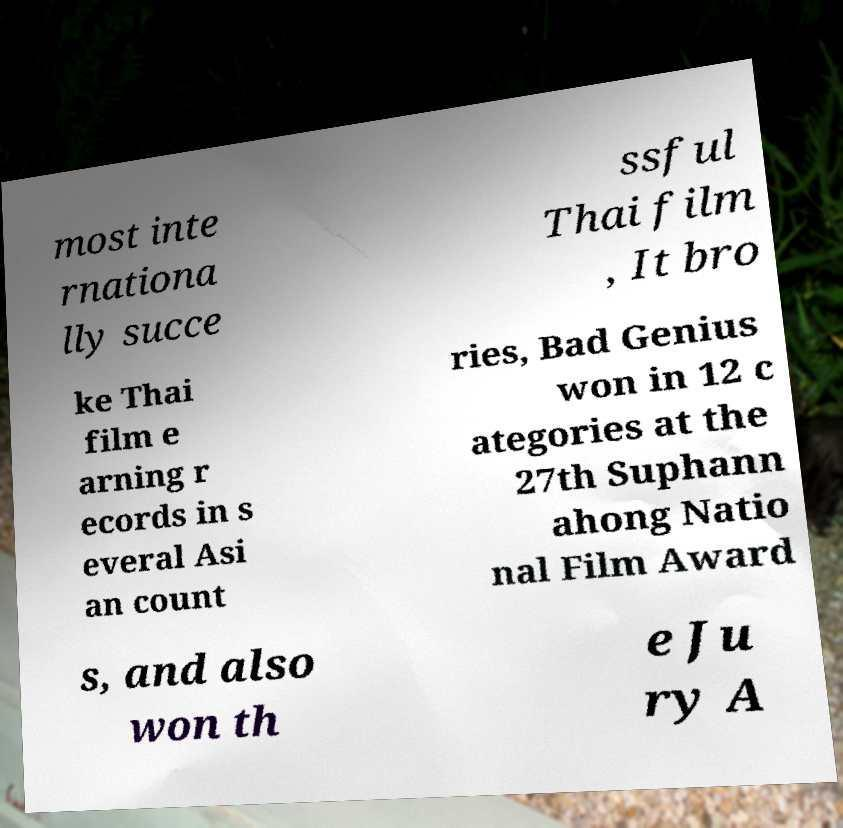I need the written content from this picture converted into text. Can you do that? most inte rnationa lly succe ssful Thai film , It bro ke Thai film e arning r ecords in s everal Asi an count ries, Bad Genius won in 12 c ategories at the 27th Suphann ahong Natio nal Film Award s, and also won th e Ju ry A 